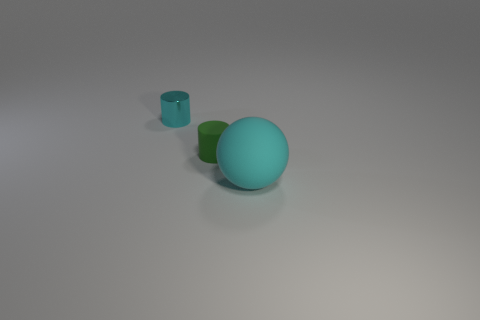Add 3 tiny green matte objects. How many objects exist? 6 Subtract all balls. How many objects are left? 2 Subtract all large blue metallic spheres. Subtract all tiny cylinders. How many objects are left? 1 Add 2 cyan cylinders. How many cyan cylinders are left? 3 Add 2 yellow metal things. How many yellow metal things exist? 2 Subtract 0 blue spheres. How many objects are left? 3 